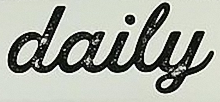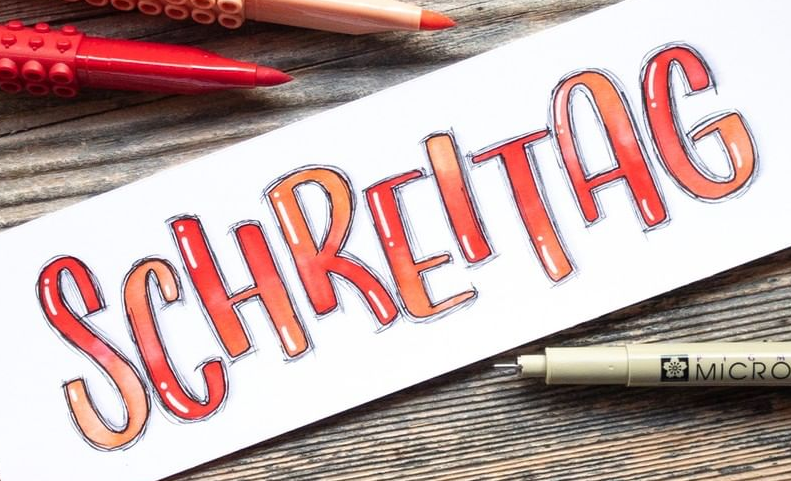Identify the words shown in these images in order, separated by a semicolon. daily; SCHREITAG 